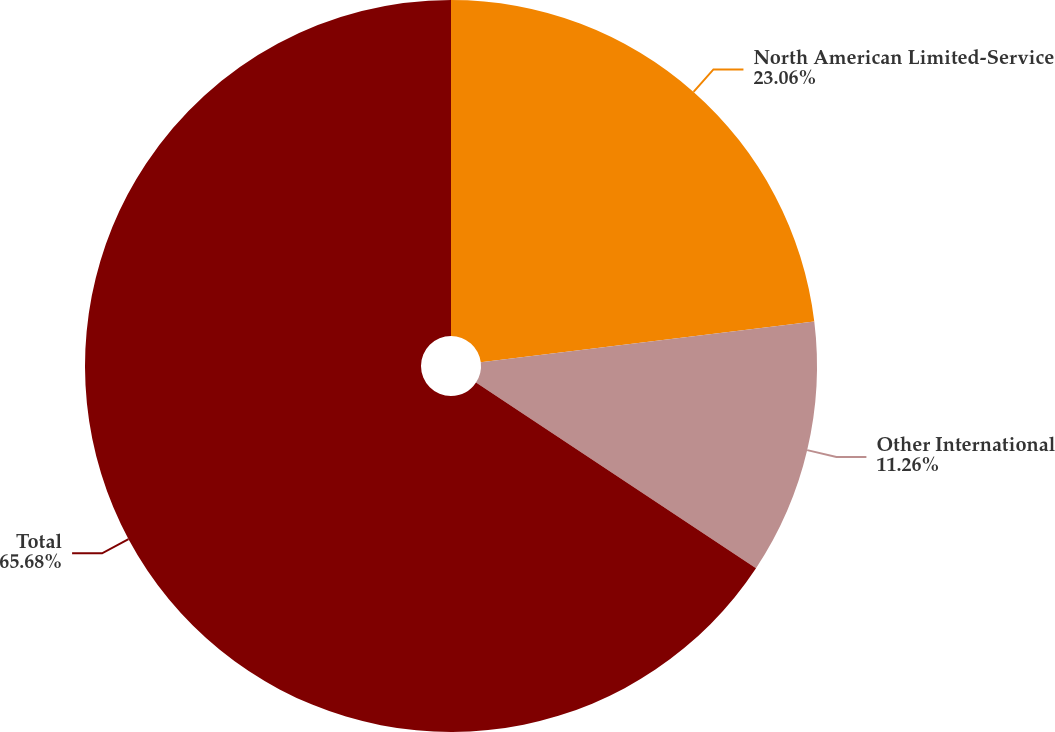<chart> <loc_0><loc_0><loc_500><loc_500><pie_chart><fcel>North American Limited-Service<fcel>Other International<fcel>Total<nl><fcel>23.06%<fcel>11.26%<fcel>65.68%<nl></chart> 